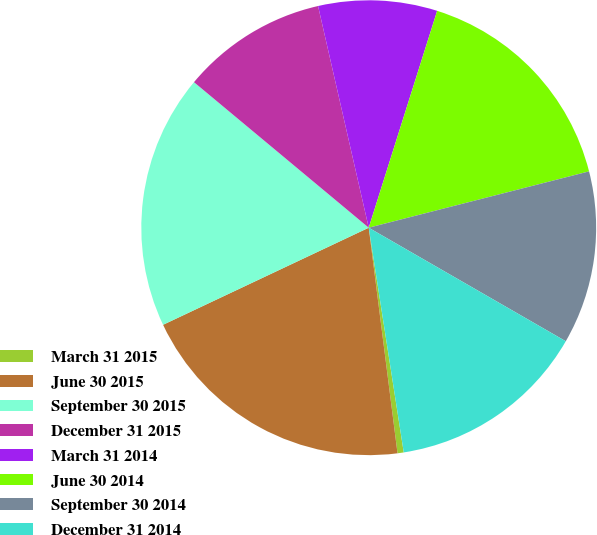Convert chart to OTSL. <chart><loc_0><loc_0><loc_500><loc_500><pie_chart><fcel>March 31 2015<fcel>June 30 2015<fcel>September 30 2015<fcel>December 31 2015<fcel>March 31 2014<fcel>June 30 2014<fcel>September 30 2014<fcel>December 31 2014<nl><fcel>0.44%<fcel>20.0%<fcel>18.07%<fcel>10.37%<fcel>8.44%<fcel>16.15%<fcel>12.3%<fcel>14.22%<nl></chart> 